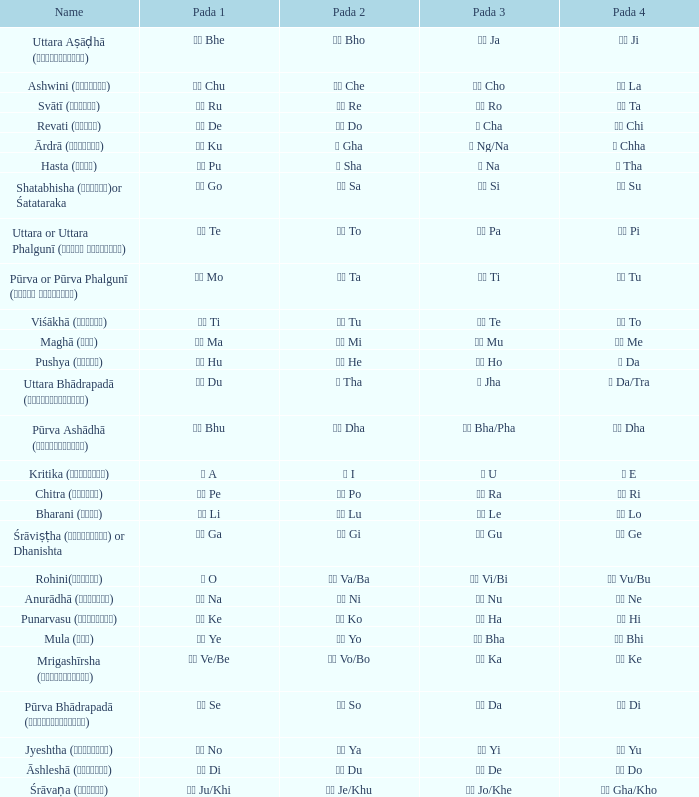Which Pada 3 has a Pada 1 of टे te? पा Pa. 